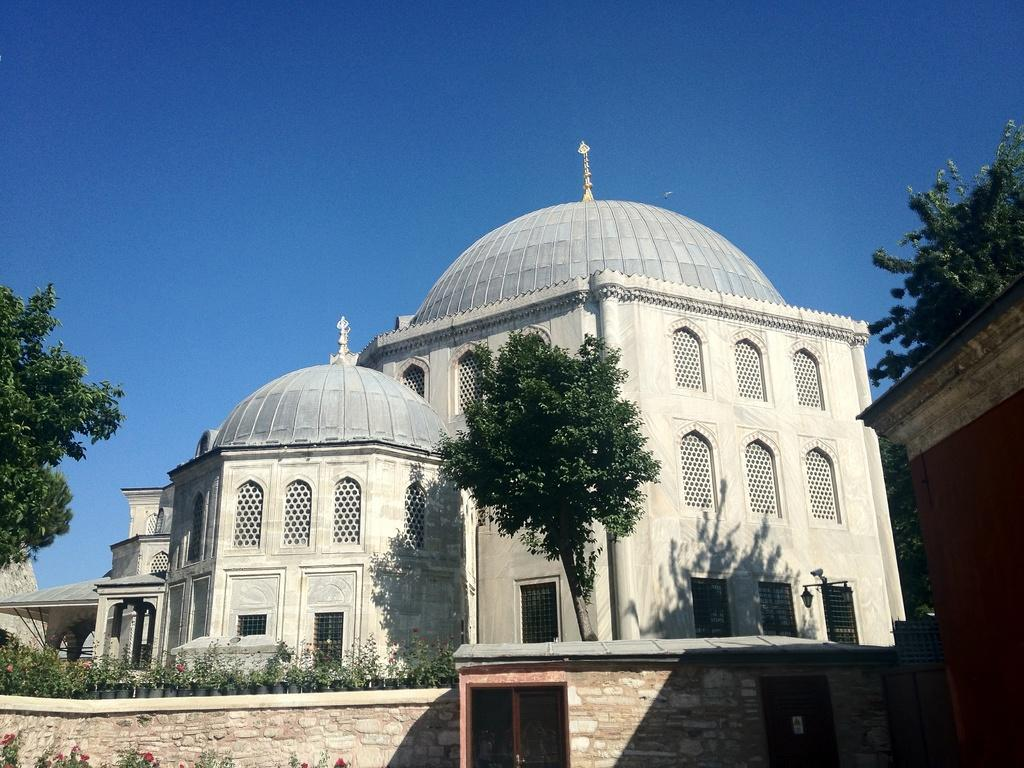What type of structure is visible in the image? There is a building in the image. What other natural elements can be seen in the image? There are plants and trees in the image. What is the condition of the sky in the image? The sky is clear in the image. Can you see anyone smiling in the image? There are no people present in the image, so it is not possible to see anyone smiling. 